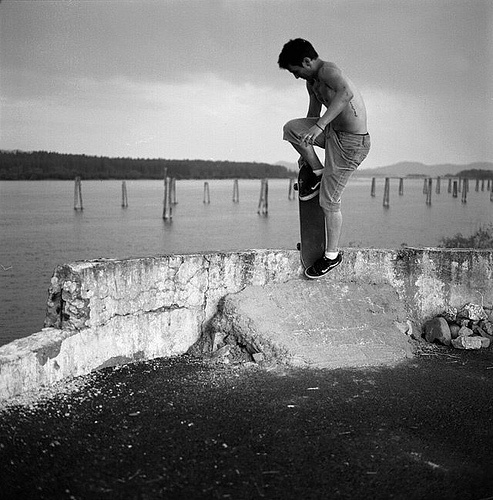Describe the objects in this image and their specific colors. I can see people in black, gray, darkgray, and lightgray tones and skateboard in black, gray, darkgray, and lightgray tones in this image. 